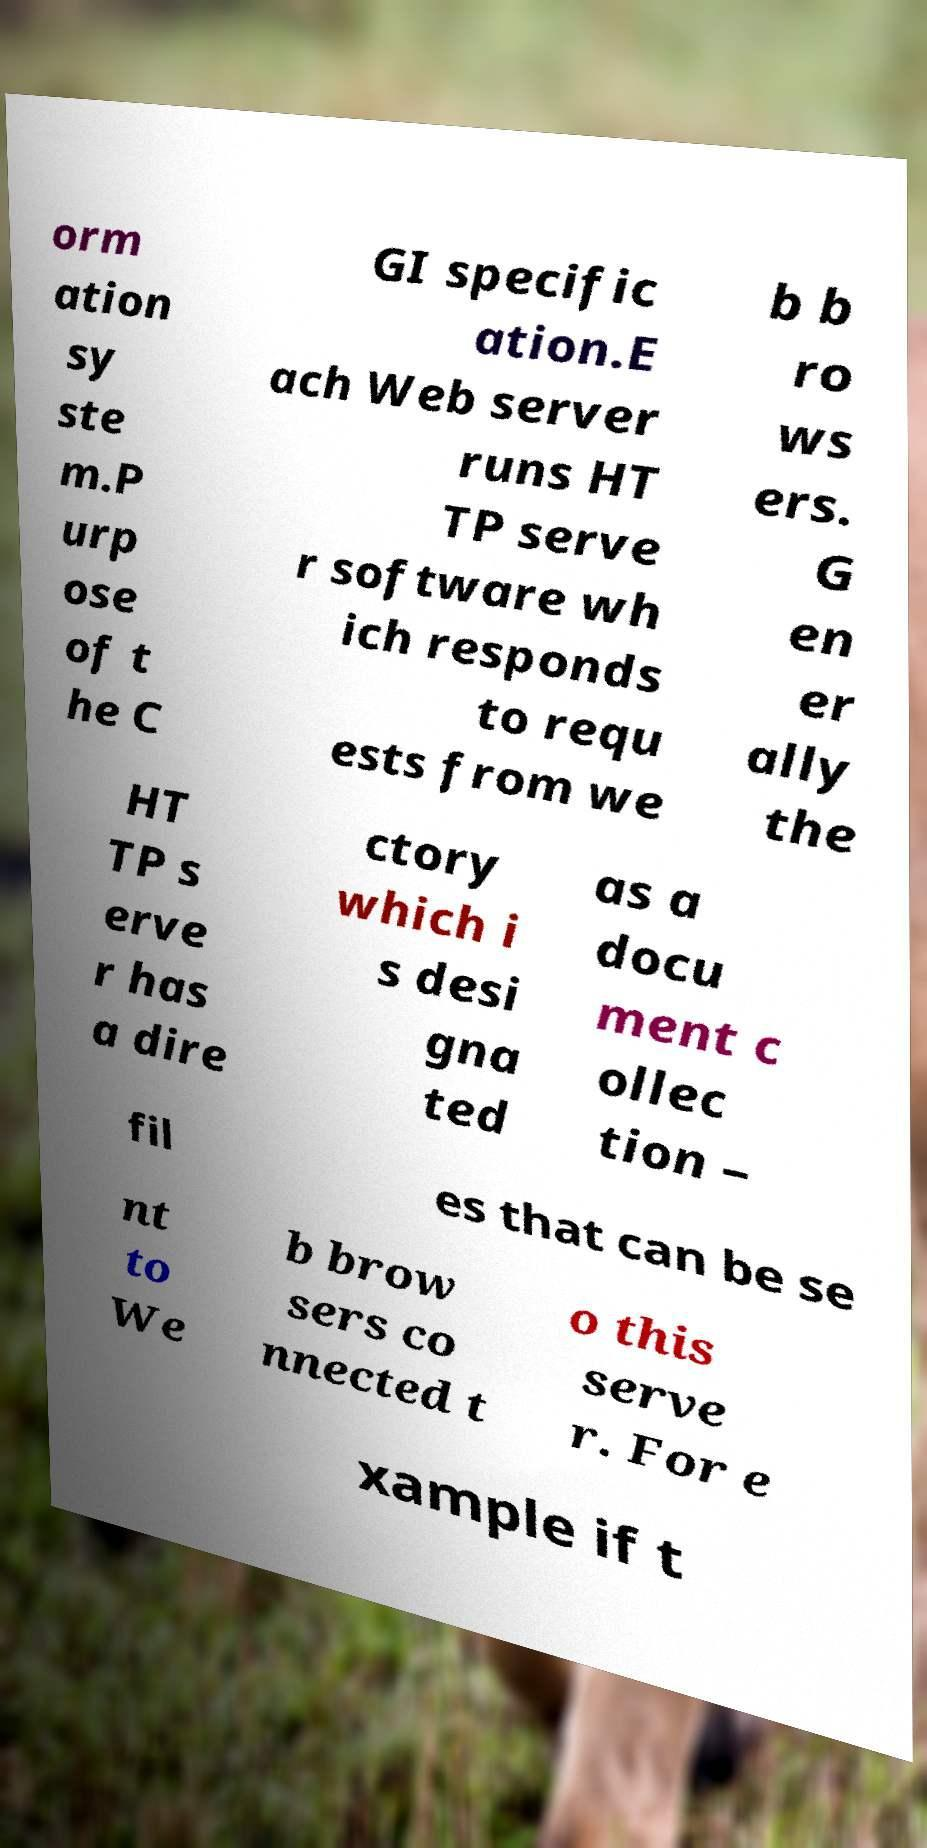Can you accurately transcribe the text from the provided image for me? orm ation sy ste m.P urp ose of t he C GI specific ation.E ach Web server runs HT TP serve r software wh ich responds to requ ests from we b b ro ws ers. G en er ally the HT TP s erve r has a dire ctory which i s desi gna ted as a docu ment c ollec tion – fil es that can be se nt to We b brow sers co nnected t o this serve r. For e xample if t 